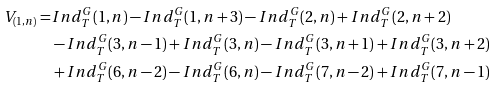Convert formula to latex. <formula><loc_0><loc_0><loc_500><loc_500>V _ { ( 1 , n ) } = & I n d _ { T } ^ { G } ( 1 , n ) - I n d _ { T } ^ { G } ( 1 , n + 3 ) - I n d _ { T } ^ { G } ( 2 , n ) + I n d _ { T } ^ { G } ( 2 , n + 2 ) \\ & - I n d _ { T } ^ { G } ( 3 , n - 1 ) + I n d _ { T } ^ { G } ( 3 , n ) - I n d _ { T } ^ { G } ( 3 , n + 1 ) + I n d _ { T } ^ { G } ( 3 , n + 2 ) \\ & + I n d _ { T } ^ { G } ( 6 , n - 2 ) - I n d _ { T } ^ { G } ( 6 , n ) - I n d _ { T } ^ { G } ( 7 , n - 2 ) + I n d _ { T } ^ { G } ( 7 , n - 1 )</formula> 